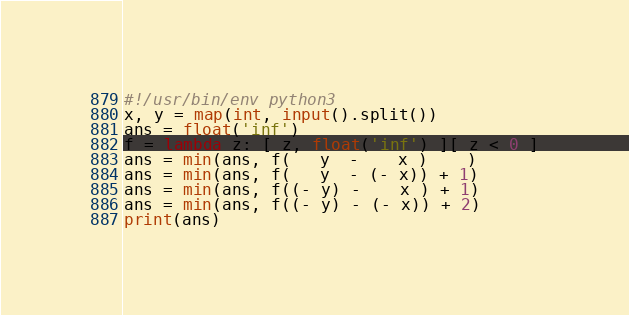Convert code to text. <code><loc_0><loc_0><loc_500><loc_500><_Python_>#!/usr/bin/env python3
x, y = map(int, input().split())
ans = float('inf')
f = lambda z: [ z, float('inf') ][ z < 0 ]
ans = min(ans, f(   y  -    x )    )
ans = min(ans, f(   y  - (- x)) + 1)
ans = min(ans, f((- y) -    x ) + 1)
ans = min(ans, f((- y) - (- x)) + 2)
print(ans)</code> 